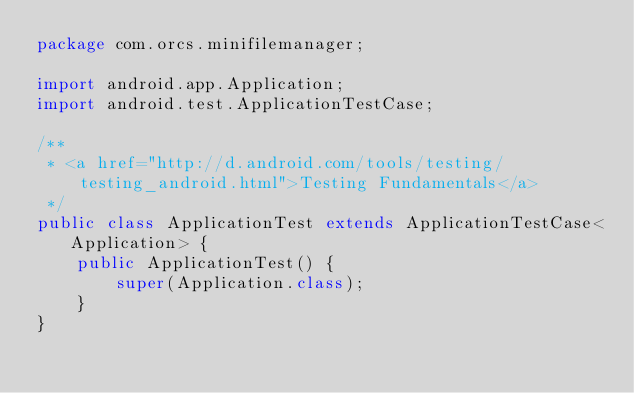Convert code to text. <code><loc_0><loc_0><loc_500><loc_500><_Java_>package com.orcs.minifilemanager;

import android.app.Application;
import android.test.ApplicationTestCase;

/**
 * <a href="http://d.android.com/tools/testing/testing_android.html">Testing Fundamentals</a>
 */
public class ApplicationTest extends ApplicationTestCase<Application> {
    public ApplicationTest() {
        super(Application.class);
    }
}</code> 